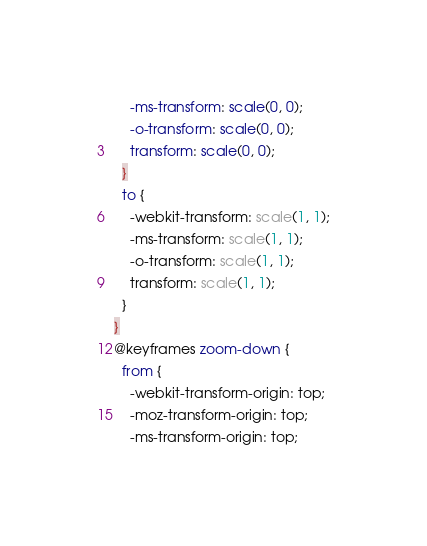<code> <loc_0><loc_0><loc_500><loc_500><_CSS_>    -ms-transform: scale(0, 0);
    -o-transform: scale(0, 0);
    transform: scale(0, 0);
  }
  to {
    -webkit-transform: scale(1, 1);
    -ms-transform: scale(1, 1);
    -o-transform: scale(1, 1);
    transform: scale(1, 1);
  }
}
@keyframes zoom-down {
  from {
    -webkit-transform-origin: top;
    -moz-transform-origin: top;
    -ms-transform-origin: top;</code> 